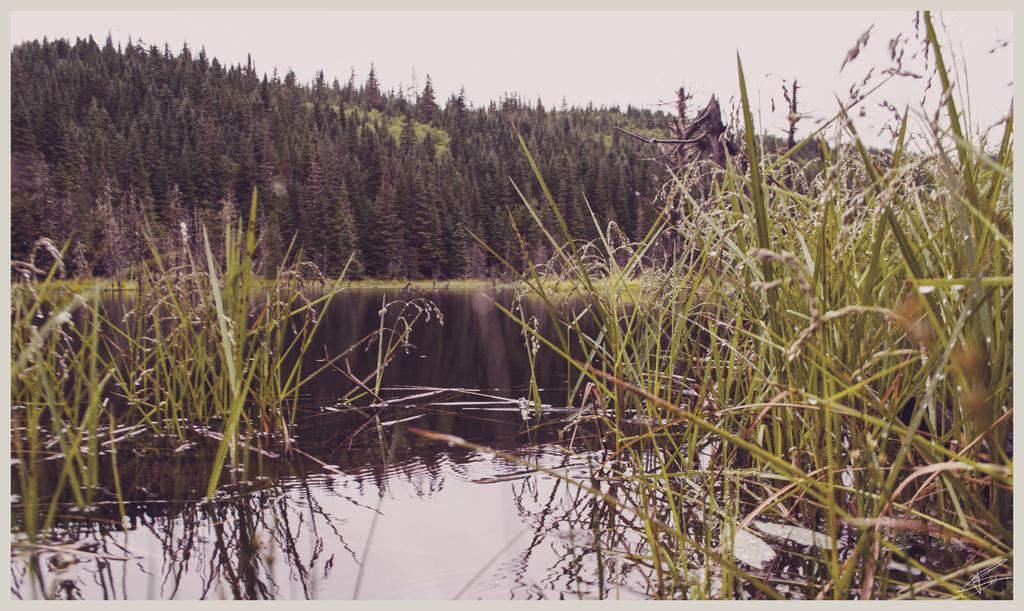What type of natural body of water is present in the image? There is a lake in the picture. What type of vegetation can be seen in the image? There is grass in the picture. What is the background of the image? There is a mountain in the backdrop of the picture. How are the trees distributed on the mountain? The mountain is covered with trees. What is the condition of the sky in the image? The sky is clear in the image. What type of fuel is being used by the loaf in the image? There is no loaf present in the image, and therefore no fuel can be associated with it. 